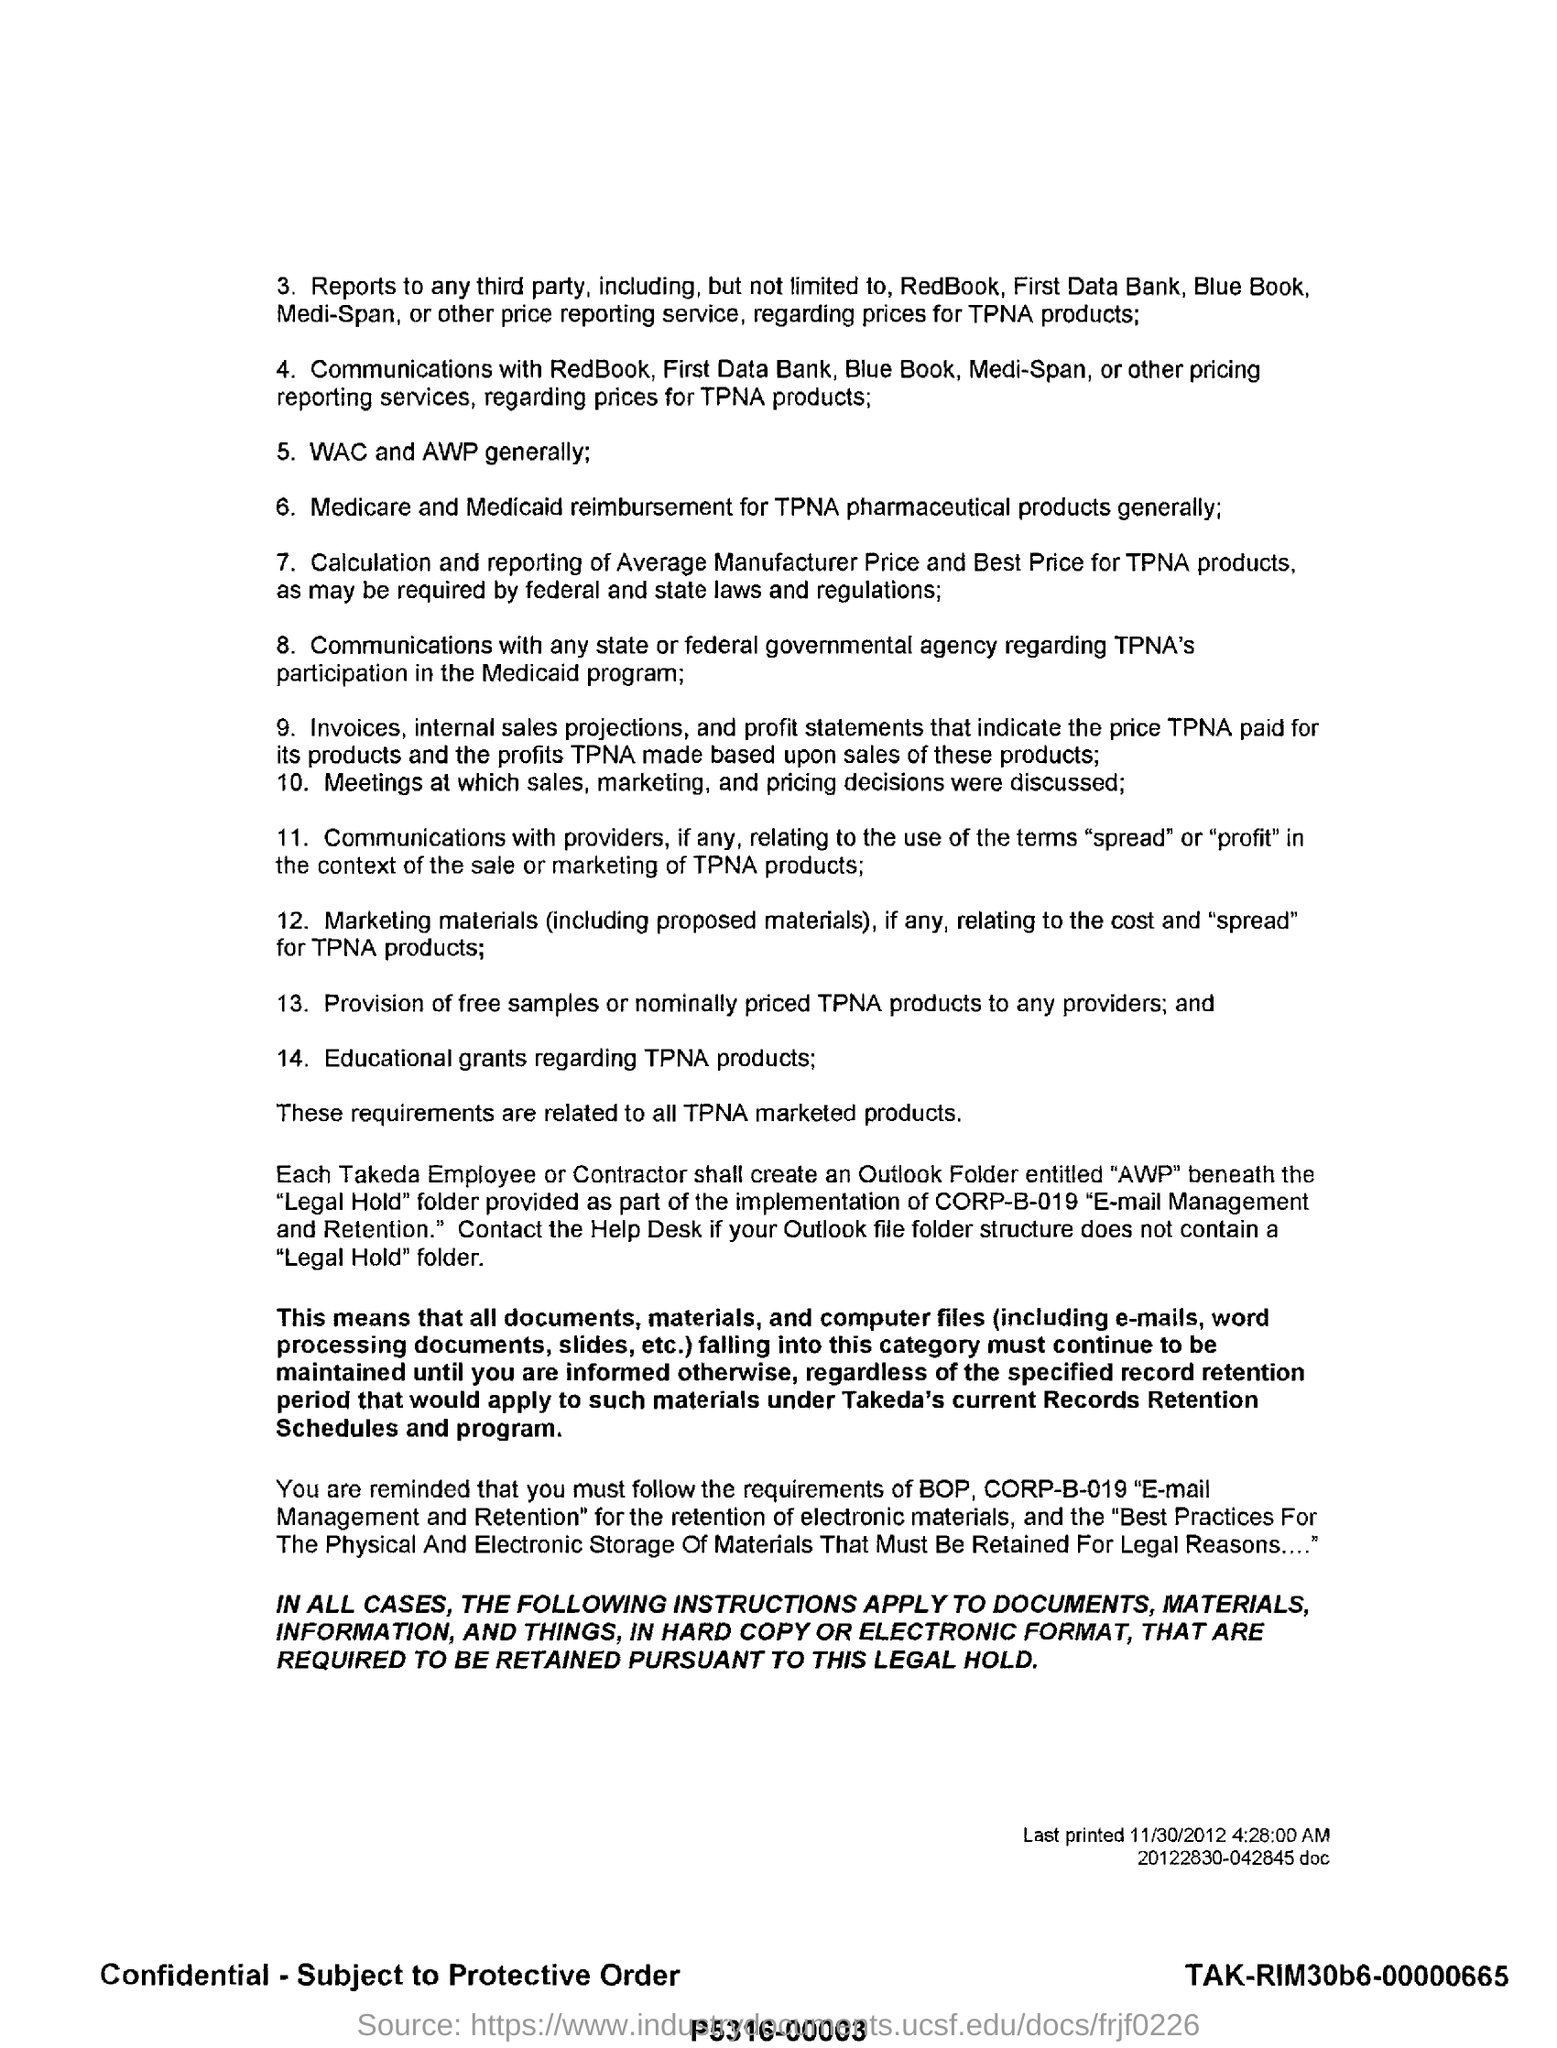What is the fifth point?
Provide a succinct answer. WAC and AWP generally;. Education grants regarding which products?
Keep it short and to the point. TPNA. What is the date this document was last printed?
Offer a very short reply. 11/30/2012. Which reimbursement for TPNA pharmaceutical products is generally given?
Your answer should be very brief. Medicare and Medicaid. 